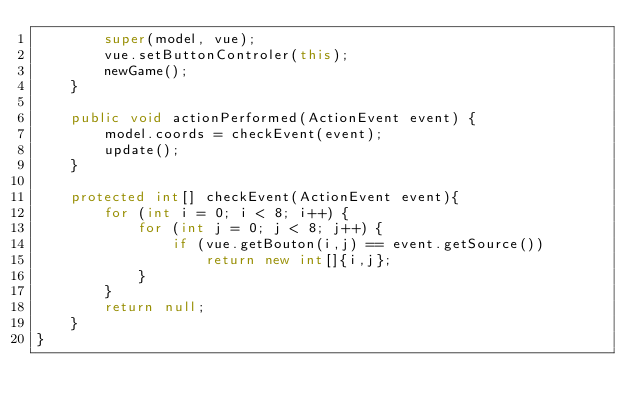<code> <loc_0><loc_0><loc_500><loc_500><_Java_>    	super(model, vue);
    	vue.setButtonControler(this);
		newGame();
    }

    public void actionPerformed(ActionEvent event) {
		model.coords = checkEvent(event);
		update();
	}

	protected int[] checkEvent(ActionEvent event){
		for (int i = 0; i < 8; i++) {
			for (int j = 0; j < 8; j++) {
				if (vue.getBouton(i,j) == event.getSource())
					return new int[]{i,j};
			}
		}
		return null;
	}
}
</code> 